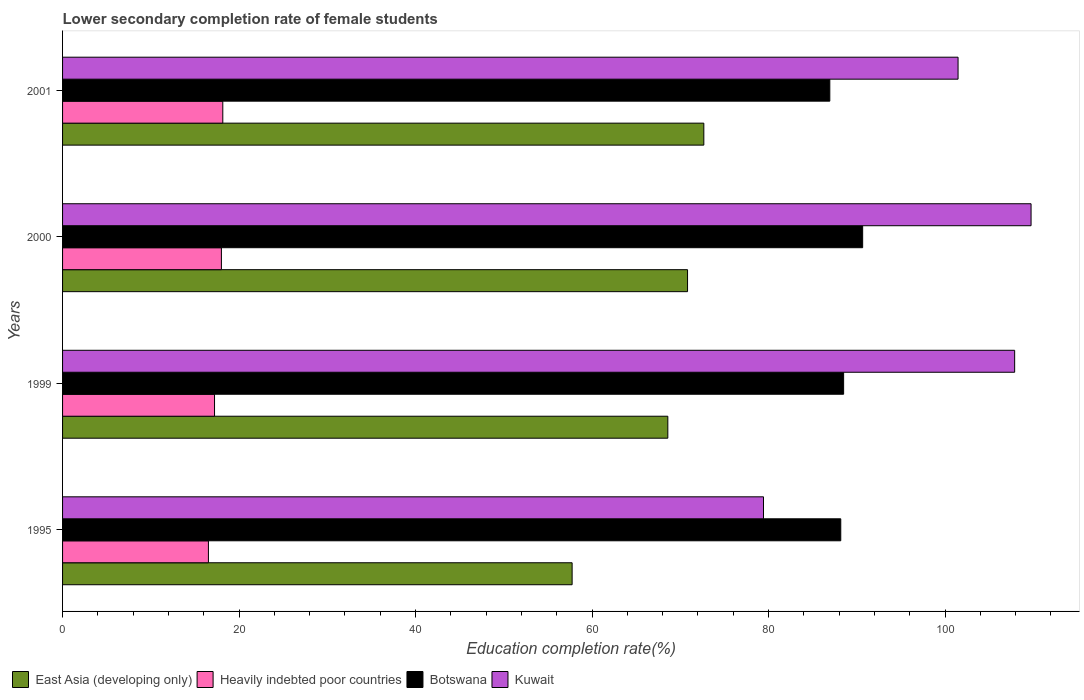How many different coloured bars are there?
Provide a short and direct response. 4. How many groups of bars are there?
Offer a very short reply. 4. Are the number of bars per tick equal to the number of legend labels?
Offer a terse response. Yes. How many bars are there on the 2nd tick from the top?
Offer a very short reply. 4. What is the lower secondary completion rate of female students in East Asia (developing only) in 1999?
Give a very brief answer. 68.59. Across all years, what is the maximum lower secondary completion rate of female students in East Asia (developing only)?
Make the answer very short. 72.67. Across all years, what is the minimum lower secondary completion rate of female students in East Asia (developing only)?
Keep it short and to the point. 57.74. In which year was the lower secondary completion rate of female students in Kuwait maximum?
Offer a very short reply. 2000. In which year was the lower secondary completion rate of female students in Kuwait minimum?
Your answer should be compact. 1995. What is the total lower secondary completion rate of female students in Kuwait in the graph?
Keep it short and to the point. 398.54. What is the difference between the lower secondary completion rate of female students in Botswana in 2000 and that in 2001?
Your answer should be compact. 3.72. What is the difference between the lower secondary completion rate of female students in Botswana in 1995 and the lower secondary completion rate of female students in Kuwait in 1999?
Your answer should be very brief. -19.7. What is the average lower secondary completion rate of female students in East Asia (developing only) per year?
Ensure brevity in your answer.  67.45. In the year 2000, what is the difference between the lower secondary completion rate of female students in Kuwait and lower secondary completion rate of female students in Botswana?
Offer a terse response. 19.08. In how many years, is the lower secondary completion rate of female students in Heavily indebted poor countries greater than 44 %?
Your response must be concise. 0. What is the ratio of the lower secondary completion rate of female students in Botswana in 1995 to that in 1999?
Your answer should be very brief. 1. Is the lower secondary completion rate of female students in East Asia (developing only) in 1999 less than that in 2000?
Make the answer very short. Yes. What is the difference between the highest and the second highest lower secondary completion rate of female students in Kuwait?
Your answer should be compact. 1.86. What is the difference between the highest and the lowest lower secondary completion rate of female students in Kuwait?
Your answer should be compact. 30.32. In how many years, is the lower secondary completion rate of female students in Heavily indebted poor countries greater than the average lower secondary completion rate of female students in Heavily indebted poor countries taken over all years?
Ensure brevity in your answer.  2. Is the sum of the lower secondary completion rate of female students in Botswana in 1999 and 2000 greater than the maximum lower secondary completion rate of female students in Kuwait across all years?
Offer a terse response. Yes. Is it the case that in every year, the sum of the lower secondary completion rate of female students in Heavily indebted poor countries and lower secondary completion rate of female students in East Asia (developing only) is greater than the sum of lower secondary completion rate of female students in Botswana and lower secondary completion rate of female students in Kuwait?
Offer a terse response. No. What does the 4th bar from the top in 2001 represents?
Provide a short and direct response. East Asia (developing only). What does the 1st bar from the bottom in 1999 represents?
Offer a very short reply. East Asia (developing only). Is it the case that in every year, the sum of the lower secondary completion rate of female students in Botswana and lower secondary completion rate of female students in Kuwait is greater than the lower secondary completion rate of female students in East Asia (developing only)?
Ensure brevity in your answer.  Yes. Are all the bars in the graph horizontal?
Keep it short and to the point. Yes. Where does the legend appear in the graph?
Your answer should be compact. Bottom left. How are the legend labels stacked?
Ensure brevity in your answer.  Horizontal. What is the title of the graph?
Make the answer very short. Lower secondary completion rate of female students. Does "Egypt, Arab Rep." appear as one of the legend labels in the graph?
Your response must be concise. No. What is the label or title of the X-axis?
Offer a very short reply. Education completion rate(%). What is the label or title of the Y-axis?
Your response must be concise. Years. What is the Education completion rate(%) in East Asia (developing only) in 1995?
Provide a succinct answer. 57.74. What is the Education completion rate(%) in Heavily indebted poor countries in 1995?
Keep it short and to the point. 16.53. What is the Education completion rate(%) of Botswana in 1995?
Your response must be concise. 88.18. What is the Education completion rate(%) in Kuwait in 1995?
Provide a short and direct response. 79.43. What is the Education completion rate(%) of East Asia (developing only) in 1999?
Offer a very short reply. 68.59. What is the Education completion rate(%) of Heavily indebted poor countries in 1999?
Offer a very short reply. 17.22. What is the Education completion rate(%) of Botswana in 1999?
Your answer should be compact. 88.51. What is the Education completion rate(%) of Kuwait in 1999?
Provide a short and direct response. 107.89. What is the Education completion rate(%) in East Asia (developing only) in 2000?
Offer a very short reply. 70.82. What is the Education completion rate(%) in Heavily indebted poor countries in 2000?
Give a very brief answer. 18. What is the Education completion rate(%) of Botswana in 2000?
Offer a very short reply. 90.66. What is the Education completion rate(%) of Kuwait in 2000?
Provide a short and direct response. 109.75. What is the Education completion rate(%) in East Asia (developing only) in 2001?
Provide a succinct answer. 72.67. What is the Education completion rate(%) of Heavily indebted poor countries in 2001?
Ensure brevity in your answer.  18.16. What is the Education completion rate(%) in Botswana in 2001?
Keep it short and to the point. 86.94. What is the Education completion rate(%) of Kuwait in 2001?
Provide a succinct answer. 101.48. Across all years, what is the maximum Education completion rate(%) of East Asia (developing only)?
Your answer should be compact. 72.67. Across all years, what is the maximum Education completion rate(%) of Heavily indebted poor countries?
Offer a very short reply. 18.16. Across all years, what is the maximum Education completion rate(%) of Botswana?
Provide a short and direct response. 90.66. Across all years, what is the maximum Education completion rate(%) in Kuwait?
Provide a succinct answer. 109.75. Across all years, what is the minimum Education completion rate(%) of East Asia (developing only)?
Give a very brief answer. 57.74. Across all years, what is the minimum Education completion rate(%) of Heavily indebted poor countries?
Your answer should be very brief. 16.53. Across all years, what is the minimum Education completion rate(%) of Botswana?
Provide a short and direct response. 86.94. Across all years, what is the minimum Education completion rate(%) of Kuwait?
Make the answer very short. 79.43. What is the total Education completion rate(%) of East Asia (developing only) in the graph?
Offer a very short reply. 269.82. What is the total Education completion rate(%) of Heavily indebted poor countries in the graph?
Offer a terse response. 69.9. What is the total Education completion rate(%) in Botswana in the graph?
Your response must be concise. 354.3. What is the total Education completion rate(%) in Kuwait in the graph?
Your answer should be compact. 398.54. What is the difference between the Education completion rate(%) of East Asia (developing only) in 1995 and that in 1999?
Offer a very short reply. -10.85. What is the difference between the Education completion rate(%) in Heavily indebted poor countries in 1995 and that in 1999?
Give a very brief answer. -0.69. What is the difference between the Education completion rate(%) in Botswana in 1995 and that in 1999?
Your response must be concise. -0.32. What is the difference between the Education completion rate(%) in Kuwait in 1995 and that in 1999?
Provide a succinct answer. -28.46. What is the difference between the Education completion rate(%) of East Asia (developing only) in 1995 and that in 2000?
Give a very brief answer. -13.08. What is the difference between the Education completion rate(%) of Heavily indebted poor countries in 1995 and that in 2000?
Your response must be concise. -1.47. What is the difference between the Education completion rate(%) of Botswana in 1995 and that in 2000?
Provide a short and direct response. -2.48. What is the difference between the Education completion rate(%) of Kuwait in 1995 and that in 2000?
Provide a short and direct response. -30.32. What is the difference between the Education completion rate(%) in East Asia (developing only) in 1995 and that in 2001?
Your answer should be very brief. -14.93. What is the difference between the Education completion rate(%) of Heavily indebted poor countries in 1995 and that in 2001?
Give a very brief answer. -1.63. What is the difference between the Education completion rate(%) of Botswana in 1995 and that in 2001?
Provide a short and direct response. 1.24. What is the difference between the Education completion rate(%) in Kuwait in 1995 and that in 2001?
Provide a succinct answer. -22.05. What is the difference between the Education completion rate(%) in East Asia (developing only) in 1999 and that in 2000?
Make the answer very short. -2.24. What is the difference between the Education completion rate(%) in Heavily indebted poor countries in 1999 and that in 2000?
Make the answer very short. -0.78. What is the difference between the Education completion rate(%) in Botswana in 1999 and that in 2000?
Your response must be concise. -2.16. What is the difference between the Education completion rate(%) in Kuwait in 1999 and that in 2000?
Keep it short and to the point. -1.86. What is the difference between the Education completion rate(%) in East Asia (developing only) in 1999 and that in 2001?
Offer a terse response. -4.08. What is the difference between the Education completion rate(%) in Heavily indebted poor countries in 1999 and that in 2001?
Give a very brief answer. -0.94. What is the difference between the Education completion rate(%) of Botswana in 1999 and that in 2001?
Keep it short and to the point. 1.56. What is the difference between the Education completion rate(%) of Kuwait in 1999 and that in 2001?
Your response must be concise. 6.41. What is the difference between the Education completion rate(%) in East Asia (developing only) in 2000 and that in 2001?
Ensure brevity in your answer.  -1.84. What is the difference between the Education completion rate(%) of Heavily indebted poor countries in 2000 and that in 2001?
Provide a short and direct response. -0.16. What is the difference between the Education completion rate(%) in Botswana in 2000 and that in 2001?
Offer a terse response. 3.72. What is the difference between the Education completion rate(%) of Kuwait in 2000 and that in 2001?
Make the answer very short. 8.27. What is the difference between the Education completion rate(%) in East Asia (developing only) in 1995 and the Education completion rate(%) in Heavily indebted poor countries in 1999?
Ensure brevity in your answer.  40.52. What is the difference between the Education completion rate(%) in East Asia (developing only) in 1995 and the Education completion rate(%) in Botswana in 1999?
Keep it short and to the point. -30.77. What is the difference between the Education completion rate(%) in East Asia (developing only) in 1995 and the Education completion rate(%) in Kuwait in 1999?
Keep it short and to the point. -50.15. What is the difference between the Education completion rate(%) of Heavily indebted poor countries in 1995 and the Education completion rate(%) of Botswana in 1999?
Make the answer very short. -71.98. What is the difference between the Education completion rate(%) in Heavily indebted poor countries in 1995 and the Education completion rate(%) in Kuwait in 1999?
Give a very brief answer. -91.36. What is the difference between the Education completion rate(%) of Botswana in 1995 and the Education completion rate(%) of Kuwait in 1999?
Make the answer very short. -19.7. What is the difference between the Education completion rate(%) in East Asia (developing only) in 1995 and the Education completion rate(%) in Heavily indebted poor countries in 2000?
Make the answer very short. 39.74. What is the difference between the Education completion rate(%) of East Asia (developing only) in 1995 and the Education completion rate(%) of Botswana in 2000?
Offer a very short reply. -32.92. What is the difference between the Education completion rate(%) of East Asia (developing only) in 1995 and the Education completion rate(%) of Kuwait in 2000?
Provide a succinct answer. -52.01. What is the difference between the Education completion rate(%) in Heavily indebted poor countries in 1995 and the Education completion rate(%) in Botswana in 2000?
Ensure brevity in your answer.  -74.14. What is the difference between the Education completion rate(%) in Heavily indebted poor countries in 1995 and the Education completion rate(%) in Kuwait in 2000?
Give a very brief answer. -93.22. What is the difference between the Education completion rate(%) of Botswana in 1995 and the Education completion rate(%) of Kuwait in 2000?
Your answer should be very brief. -21.56. What is the difference between the Education completion rate(%) of East Asia (developing only) in 1995 and the Education completion rate(%) of Heavily indebted poor countries in 2001?
Your answer should be compact. 39.59. What is the difference between the Education completion rate(%) of East Asia (developing only) in 1995 and the Education completion rate(%) of Botswana in 2001?
Your response must be concise. -29.2. What is the difference between the Education completion rate(%) of East Asia (developing only) in 1995 and the Education completion rate(%) of Kuwait in 2001?
Ensure brevity in your answer.  -43.73. What is the difference between the Education completion rate(%) in Heavily indebted poor countries in 1995 and the Education completion rate(%) in Botswana in 2001?
Provide a short and direct response. -70.42. What is the difference between the Education completion rate(%) in Heavily indebted poor countries in 1995 and the Education completion rate(%) in Kuwait in 2001?
Provide a succinct answer. -84.95. What is the difference between the Education completion rate(%) of Botswana in 1995 and the Education completion rate(%) of Kuwait in 2001?
Provide a succinct answer. -13.29. What is the difference between the Education completion rate(%) in East Asia (developing only) in 1999 and the Education completion rate(%) in Heavily indebted poor countries in 2000?
Provide a succinct answer. 50.59. What is the difference between the Education completion rate(%) of East Asia (developing only) in 1999 and the Education completion rate(%) of Botswana in 2000?
Your answer should be very brief. -22.08. What is the difference between the Education completion rate(%) in East Asia (developing only) in 1999 and the Education completion rate(%) in Kuwait in 2000?
Give a very brief answer. -41.16. What is the difference between the Education completion rate(%) of Heavily indebted poor countries in 1999 and the Education completion rate(%) of Botswana in 2000?
Keep it short and to the point. -73.44. What is the difference between the Education completion rate(%) of Heavily indebted poor countries in 1999 and the Education completion rate(%) of Kuwait in 2000?
Your answer should be very brief. -92.53. What is the difference between the Education completion rate(%) of Botswana in 1999 and the Education completion rate(%) of Kuwait in 2000?
Make the answer very short. -21.24. What is the difference between the Education completion rate(%) of East Asia (developing only) in 1999 and the Education completion rate(%) of Heavily indebted poor countries in 2001?
Your response must be concise. 50.43. What is the difference between the Education completion rate(%) of East Asia (developing only) in 1999 and the Education completion rate(%) of Botswana in 2001?
Offer a terse response. -18.36. What is the difference between the Education completion rate(%) of East Asia (developing only) in 1999 and the Education completion rate(%) of Kuwait in 2001?
Offer a very short reply. -32.89. What is the difference between the Education completion rate(%) of Heavily indebted poor countries in 1999 and the Education completion rate(%) of Botswana in 2001?
Your answer should be very brief. -69.72. What is the difference between the Education completion rate(%) in Heavily indebted poor countries in 1999 and the Education completion rate(%) in Kuwait in 2001?
Your answer should be very brief. -84.26. What is the difference between the Education completion rate(%) in Botswana in 1999 and the Education completion rate(%) in Kuwait in 2001?
Provide a succinct answer. -12.97. What is the difference between the Education completion rate(%) of East Asia (developing only) in 2000 and the Education completion rate(%) of Heavily indebted poor countries in 2001?
Your answer should be compact. 52.67. What is the difference between the Education completion rate(%) of East Asia (developing only) in 2000 and the Education completion rate(%) of Botswana in 2001?
Make the answer very short. -16.12. What is the difference between the Education completion rate(%) of East Asia (developing only) in 2000 and the Education completion rate(%) of Kuwait in 2001?
Offer a very short reply. -30.65. What is the difference between the Education completion rate(%) in Heavily indebted poor countries in 2000 and the Education completion rate(%) in Botswana in 2001?
Give a very brief answer. -68.94. What is the difference between the Education completion rate(%) of Heavily indebted poor countries in 2000 and the Education completion rate(%) of Kuwait in 2001?
Keep it short and to the point. -83.48. What is the difference between the Education completion rate(%) of Botswana in 2000 and the Education completion rate(%) of Kuwait in 2001?
Provide a succinct answer. -10.81. What is the average Education completion rate(%) of East Asia (developing only) per year?
Ensure brevity in your answer.  67.45. What is the average Education completion rate(%) in Heavily indebted poor countries per year?
Give a very brief answer. 17.48. What is the average Education completion rate(%) of Botswana per year?
Your response must be concise. 88.58. What is the average Education completion rate(%) of Kuwait per year?
Give a very brief answer. 99.64. In the year 1995, what is the difference between the Education completion rate(%) in East Asia (developing only) and Education completion rate(%) in Heavily indebted poor countries?
Your answer should be compact. 41.21. In the year 1995, what is the difference between the Education completion rate(%) in East Asia (developing only) and Education completion rate(%) in Botswana?
Provide a short and direct response. -30.44. In the year 1995, what is the difference between the Education completion rate(%) in East Asia (developing only) and Education completion rate(%) in Kuwait?
Your answer should be very brief. -21.69. In the year 1995, what is the difference between the Education completion rate(%) in Heavily indebted poor countries and Education completion rate(%) in Botswana?
Offer a very short reply. -71.66. In the year 1995, what is the difference between the Education completion rate(%) of Heavily indebted poor countries and Education completion rate(%) of Kuwait?
Provide a succinct answer. -62.9. In the year 1995, what is the difference between the Education completion rate(%) of Botswana and Education completion rate(%) of Kuwait?
Provide a short and direct response. 8.76. In the year 1999, what is the difference between the Education completion rate(%) of East Asia (developing only) and Education completion rate(%) of Heavily indebted poor countries?
Ensure brevity in your answer.  51.37. In the year 1999, what is the difference between the Education completion rate(%) of East Asia (developing only) and Education completion rate(%) of Botswana?
Keep it short and to the point. -19.92. In the year 1999, what is the difference between the Education completion rate(%) in East Asia (developing only) and Education completion rate(%) in Kuwait?
Provide a succinct answer. -39.3. In the year 1999, what is the difference between the Education completion rate(%) of Heavily indebted poor countries and Education completion rate(%) of Botswana?
Offer a terse response. -71.29. In the year 1999, what is the difference between the Education completion rate(%) of Heavily indebted poor countries and Education completion rate(%) of Kuwait?
Make the answer very short. -90.67. In the year 1999, what is the difference between the Education completion rate(%) in Botswana and Education completion rate(%) in Kuwait?
Offer a terse response. -19.38. In the year 2000, what is the difference between the Education completion rate(%) in East Asia (developing only) and Education completion rate(%) in Heavily indebted poor countries?
Your response must be concise. 52.82. In the year 2000, what is the difference between the Education completion rate(%) of East Asia (developing only) and Education completion rate(%) of Botswana?
Your answer should be compact. -19.84. In the year 2000, what is the difference between the Education completion rate(%) of East Asia (developing only) and Education completion rate(%) of Kuwait?
Your answer should be compact. -38.93. In the year 2000, what is the difference between the Education completion rate(%) of Heavily indebted poor countries and Education completion rate(%) of Botswana?
Provide a short and direct response. -72.67. In the year 2000, what is the difference between the Education completion rate(%) of Heavily indebted poor countries and Education completion rate(%) of Kuwait?
Your answer should be compact. -91.75. In the year 2000, what is the difference between the Education completion rate(%) of Botswana and Education completion rate(%) of Kuwait?
Your answer should be compact. -19.08. In the year 2001, what is the difference between the Education completion rate(%) of East Asia (developing only) and Education completion rate(%) of Heavily indebted poor countries?
Make the answer very short. 54.51. In the year 2001, what is the difference between the Education completion rate(%) of East Asia (developing only) and Education completion rate(%) of Botswana?
Your answer should be compact. -14.28. In the year 2001, what is the difference between the Education completion rate(%) in East Asia (developing only) and Education completion rate(%) in Kuwait?
Give a very brief answer. -28.81. In the year 2001, what is the difference between the Education completion rate(%) in Heavily indebted poor countries and Education completion rate(%) in Botswana?
Your answer should be very brief. -68.79. In the year 2001, what is the difference between the Education completion rate(%) of Heavily indebted poor countries and Education completion rate(%) of Kuwait?
Offer a terse response. -83.32. In the year 2001, what is the difference between the Education completion rate(%) of Botswana and Education completion rate(%) of Kuwait?
Offer a very short reply. -14.53. What is the ratio of the Education completion rate(%) of East Asia (developing only) in 1995 to that in 1999?
Ensure brevity in your answer.  0.84. What is the ratio of the Education completion rate(%) of Heavily indebted poor countries in 1995 to that in 1999?
Offer a terse response. 0.96. What is the ratio of the Education completion rate(%) of Botswana in 1995 to that in 1999?
Provide a succinct answer. 1. What is the ratio of the Education completion rate(%) of Kuwait in 1995 to that in 1999?
Make the answer very short. 0.74. What is the ratio of the Education completion rate(%) in East Asia (developing only) in 1995 to that in 2000?
Your response must be concise. 0.82. What is the ratio of the Education completion rate(%) in Heavily indebted poor countries in 1995 to that in 2000?
Your answer should be very brief. 0.92. What is the ratio of the Education completion rate(%) of Botswana in 1995 to that in 2000?
Offer a very short reply. 0.97. What is the ratio of the Education completion rate(%) of Kuwait in 1995 to that in 2000?
Ensure brevity in your answer.  0.72. What is the ratio of the Education completion rate(%) of East Asia (developing only) in 1995 to that in 2001?
Give a very brief answer. 0.79. What is the ratio of the Education completion rate(%) in Heavily indebted poor countries in 1995 to that in 2001?
Provide a short and direct response. 0.91. What is the ratio of the Education completion rate(%) of Botswana in 1995 to that in 2001?
Your answer should be very brief. 1.01. What is the ratio of the Education completion rate(%) of Kuwait in 1995 to that in 2001?
Provide a succinct answer. 0.78. What is the ratio of the Education completion rate(%) of East Asia (developing only) in 1999 to that in 2000?
Make the answer very short. 0.97. What is the ratio of the Education completion rate(%) in Heavily indebted poor countries in 1999 to that in 2000?
Keep it short and to the point. 0.96. What is the ratio of the Education completion rate(%) in Botswana in 1999 to that in 2000?
Your answer should be compact. 0.98. What is the ratio of the Education completion rate(%) of Kuwait in 1999 to that in 2000?
Your answer should be very brief. 0.98. What is the ratio of the Education completion rate(%) in East Asia (developing only) in 1999 to that in 2001?
Offer a very short reply. 0.94. What is the ratio of the Education completion rate(%) of Heavily indebted poor countries in 1999 to that in 2001?
Offer a very short reply. 0.95. What is the ratio of the Education completion rate(%) in Botswana in 1999 to that in 2001?
Your response must be concise. 1.02. What is the ratio of the Education completion rate(%) in Kuwait in 1999 to that in 2001?
Provide a short and direct response. 1.06. What is the ratio of the Education completion rate(%) in East Asia (developing only) in 2000 to that in 2001?
Ensure brevity in your answer.  0.97. What is the ratio of the Education completion rate(%) of Botswana in 2000 to that in 2001?
Keep it short and to the point. 1.04. What is the ratio of the Education completion rate(%) in Kuwait in 2000 to that in 2001?
Keep it short and to the point. 1.08. What is the difference between the highest and the second highest Education completion rate(%) of East Asia (developing only)?
Make the answer very short. 1.84. What is the difference between the highest and the second highest Education completion rate(%) of Heavily indebted poor countries?
Your response must be concise. 0.16. What is the difference between the highest and the second highest Education completion rate(%) of Botswana?
Offer a terse response. 2.16. What is the difference between the highest and the second highest Education completion rate(%) of Kuwait?
Provide a short and direct response. 1.86. What is the difference between the highest and the lowest Education completion rate(%) in East Asia (developing only)?
Offer a very short reply. 14.93. What is the difference between the highest and the lowest Education completion rate(%) of Heavily indebted poor countries?
Your answer should be very brief. 1.63. What is the difference between the highest and the lowest Education completion rate(%) of Botswana?
Offer a very short reply. 3.72. What is the difference between the highest and the lowest Education completion rate(%) in Kuwait?
Give a very brief answer. 30.32. 